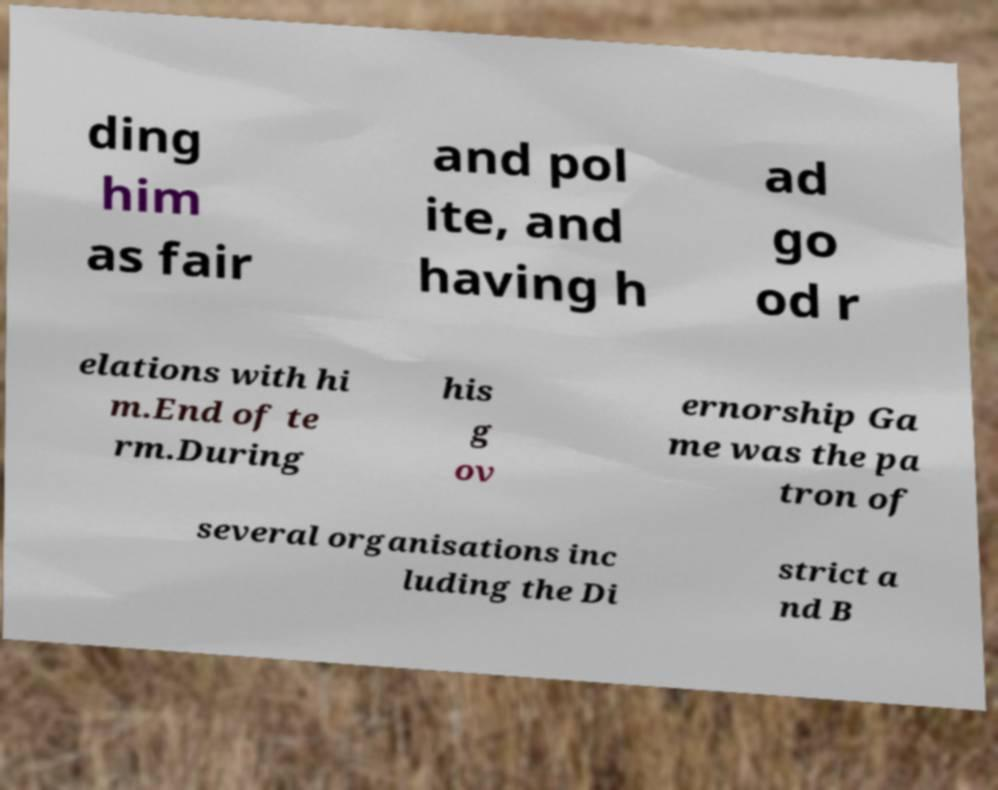Please identify and transcribe the text found in this image. ding him as fair and pol ite, and having h ad go od r elations with hi m.End of te rm.During his g ov ernorship Ga me was the pa tron of several organisations inc luding the Di strict a nd B 